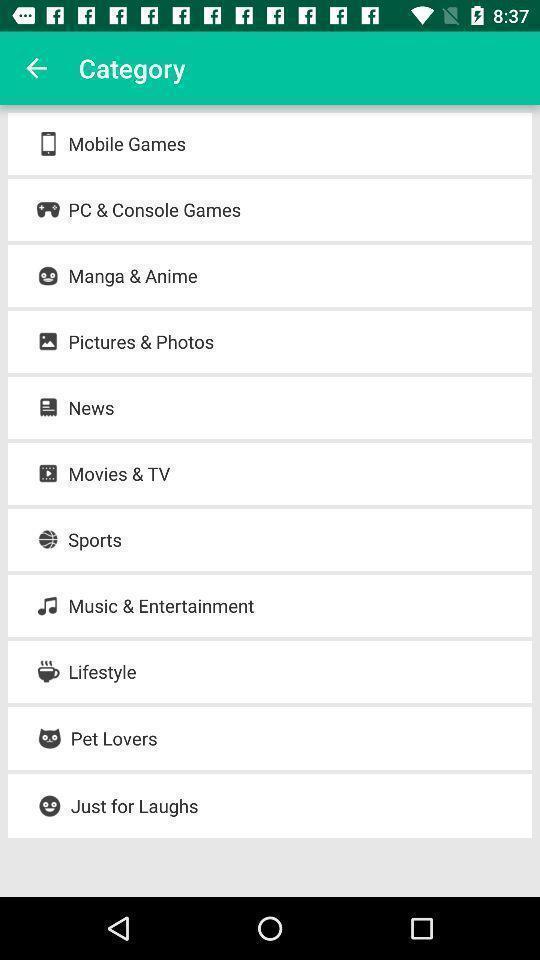What can you discern from this picture? Screen shows list of categories. 